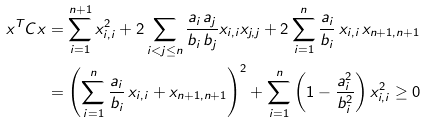Convert formula to latex. <formula><loc_0><loc_0><loc_500><loc_500>x ^ { T } C x & = \sum _ { i = 1 } ^ { n + 1 } x _ { i , i } ^ { 2 } + 2 \sum _ { i < j \leq n } \frac { a _ { i } \, a _ { j } } { b _ { i } \, b _ { j } } x _ { i , i } x _ { j , j } + 2 \sum _ { i = 1 } ^ { n } \frac { a _ { i } } { b _ { i } } \, x _ { i , i } \, x _ { n + 1 , n + 1 } \\ & = \left ( \sum _ { i = 1 } ^ { n } \frac { a _ { i } } { b _ { i } } \, x _ { i , i } + x _ { n + 1 , n + 1 } \right ) ^ { 2 } + \sum _ { i = 1 } ^ { n } \left ( 1 - \frac { a _ { i } ^ { 2 } } { b _ { i } ^ { 2 } } \right ) x _ { i , i } ^ { 2 } \geq 0</formula> 